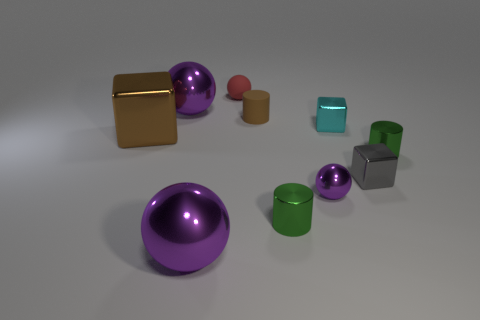Subtract all purple spheres. How many spheres are left? 1 Subtract all brown cylinders. How many cylinders are left? 2 Subtract 3 blocks. How many blocks are left? 0 Subtract all yellow blocks. Subtract all red cylinders. How many blocks are left? 3 Subtract all blue spheres. How many gray cylinders are left? 0 Subtract all gray objects. Subtract all tiny spheres. How many objects are left? 7 Add 8 large purple shiny balls. How many large purple shiny balls are left? 10 Add 5 tiny matte cylinders. How many tiny matte cylinders exist? 6 Subtract 0 purple cubes. How many objects are left? 10 Subtract all cylinders. How many objects are left? 7 